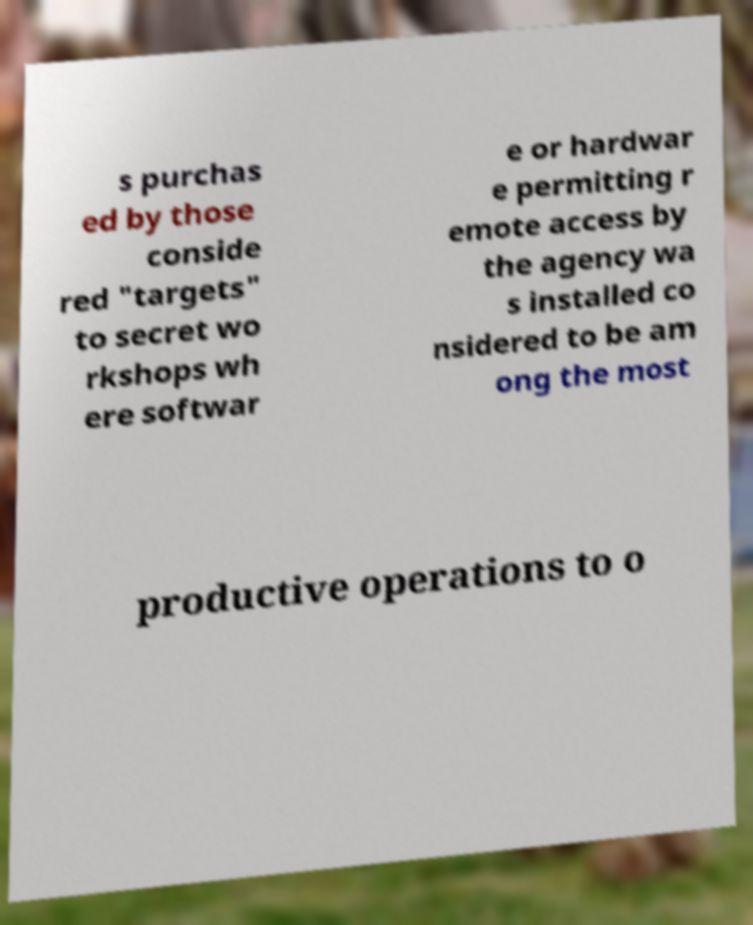Could you assist in decoding the text presented in this image and type it out clearly? s purchas ed by those conside red "targets" to secret wo rkshops wh ere softwar e or hardwar e permitting r emote access by the agency wa s installed co nsidered to be am ong the most productive operations to o 